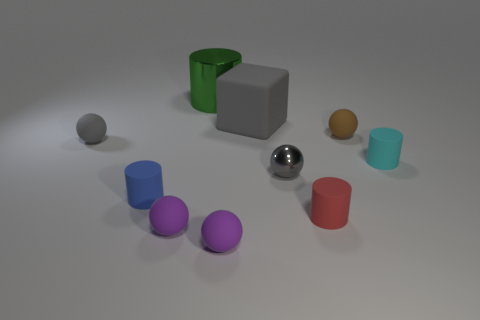Subtract all brown matte balls. How many balls are left? 4 Subtract all cubes. How many objects are left? 9 Subtract 1 red cylinders. How many objects are left? 9 Subtract 4 balls. How many balls are left? 1 Subtract all blue spheres. Subtract all blue blocks. How many spheres are left? 5 Subtract all purple spheres. How many yellow cylinders are left? 0 Subtract all large gray cubes. Subtract all cyan rubber cylinders. How many objects are left? 8 Add 9 gray matte balls. How many gray matte balls are left? 10 Add 6 gray metal balls. How many gray metal balls exist? 7 Subtract all brown spheres. How many spheres are left? 4 